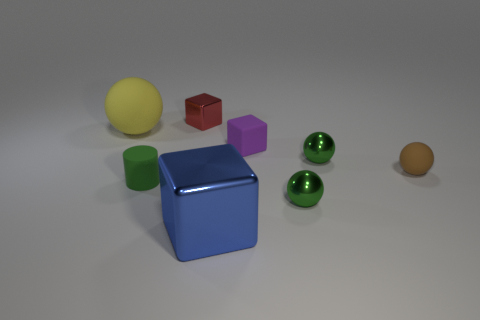Add 1 blue cubes. How many objects exist? 9 Subtract all cylinders. How many objects are left? 7 Add 1 gray matte cylinders. How many gray matte cylinders exist? 1 Subtract 1 purple blocks. How many objects are left? 7 Subtract all yellow things. Subtract all tiny brown objects. How many objects are left? 6 Add 8 red shiny blocks. How many red shiny blocks are left? 9 